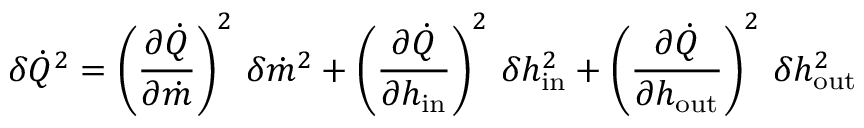Convert formula to latex. <formula><loc_0><loc_0><loc_500><loc_500>\delta \dot { Q } ^ { 2 } = \left ( \frac { \partial \dot { Q } } { \partial \dot { m } } \right ) ^ { 2 } \, \delta \dot { m } ^ { 2 } + \left ( \frac { \partial \dot { Q } } { \partial h _ { i n } } \right ) ^ { 2 } \, \delta h _ { i n } ^ { 2 } + \left ( \frac { \partial \dot { Q } } { \partial h _ { o u t } } \right ) ^ { 2 } \, \delta h _ { o u t } ^ { 2 }</formula> 